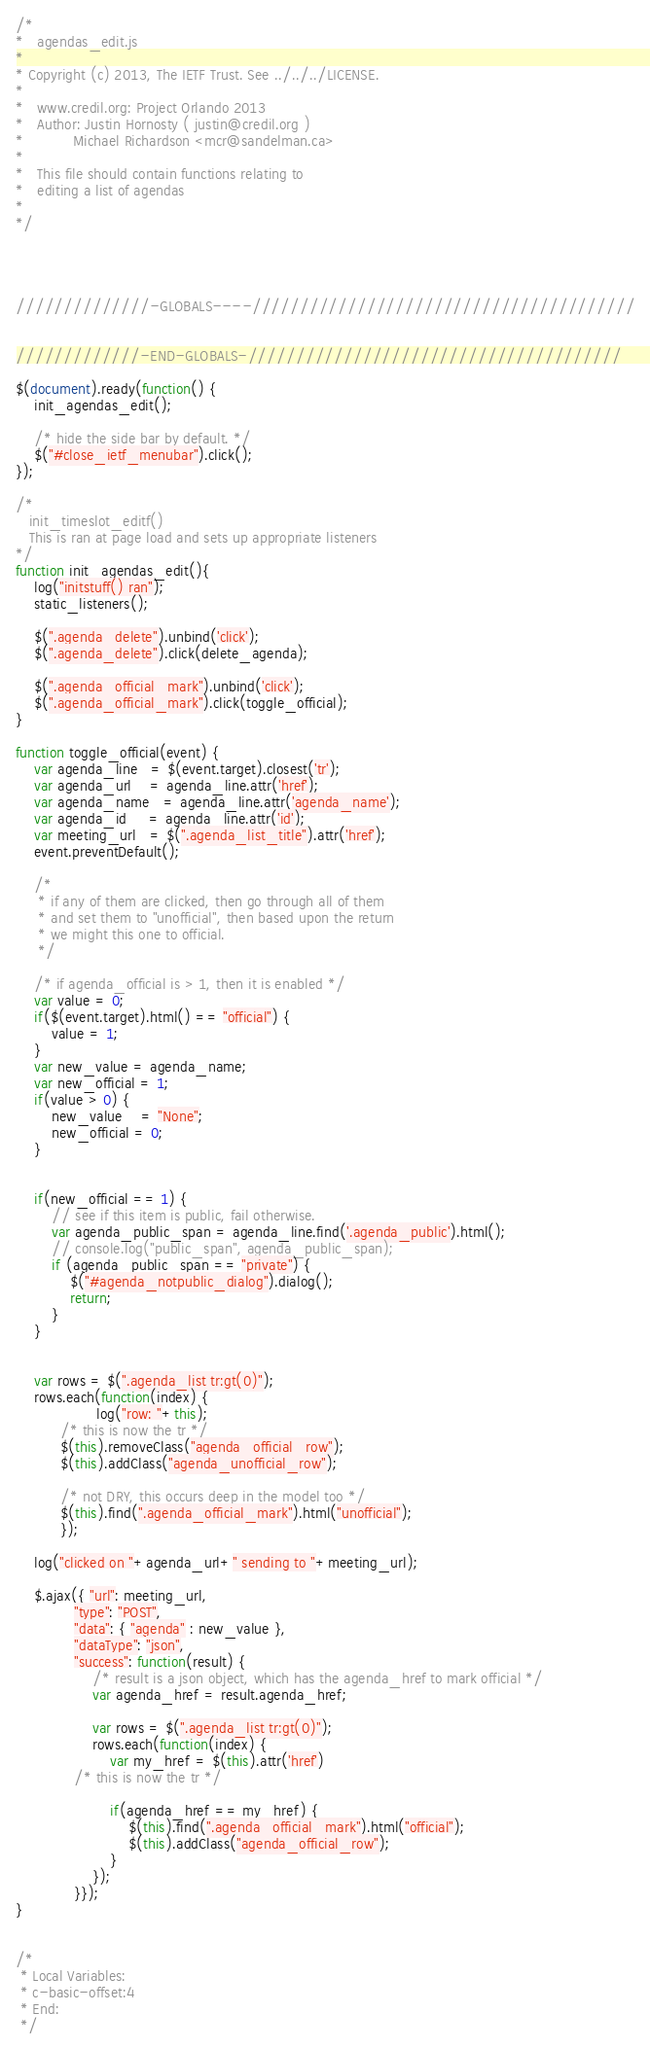Convert code to text. <code><loc_0><loc_0><loc_500><loc_500><_JavaScript_>/*
*   agendas_edit.js
*
* Copyright (c) 2013, The IETF Trust. See ../../../LICENSE.
*
*   www.credil.org: Project Orlando 2013 
*   Author: Justin Hornosty ( justin@credil.org )
*           Michael Richardson <mcr@sandelman.ca>
*
*   This file should contain functions relating to
*   editing a list of agendas
*
*/




//////////////-GLOBALS----////////////////////////////////////////


/////////////-END-GLOBALS-///////////////////////////////////////

$(document).ready(function() {
    init_agendas_edit();

    /* hide the side bar by default. */
    $("#close_ietf_menubar").click();
});

/*
   init_timeslot_editf()
   This is ran at page load and sets up appropriate listeners
*/
function init_agendas_edit(){
    log("initstuff() ran");
    static_listeners();

    $(".agenda_delete").unbind('click');
    $(".agenda_delete").click(delete_agenda);

    $(".agenda_official_mark").unbind('click');
    $(".agenda_official_mark").click(toggle_official);
}

function toggle_official(event) {
    var agenda_line   = $(event.target).closest('tr');
    var agenda_url    = agenda_line.attr('href');
    var agenda_name   = agenda_line.attr('agenda_name');
    var agenda_id     = agenda_line.attr('id');
    var meeting_url   = $(".agenda_list_title").attr('href');
    event.preventDefault();

    /*
     * if any of them are clicked, then go through all of them
     * and set them to "unofficial", then based upon the return
     * we might this one to official.
     */

    /* if agenda_official is > 1, then it is enabled */
    var value = 0;
    if($(event.target).html() == "official") {
        value = 1;
    }
    var new_value = agenda_name;
    var new_official = 1;
    if(value > 0) {
        new_value    = "None";
        new_official = 0;
    }


    if(new_official == 1) {
        // see if this item is public, fail otherwise.
        var agenda_public_span = agenda_line.find('.agenda_public').html();
        // console.log("public_span", agenda_public_span);
        if (agenda_public_span == "private") {
            $("#agenda_notpublic_dialog").dialog();
            return;
        }
    }


    var rows = $(".agenda_list tr:gt(0)");
    rows.each(function(index) {
                  log("row: "+this);
		  /* this is now the tr */
		  $(this).removeClass("agenda_official_row");
		  $(this).addClass("agenda_unofficial_row");

		  /* not DRY, this occurs deep in the model too */
		  $(this).find(".agenda_official_mark").html("unofficial");
	      });

    log("clicked on "+agenda_url+" sending to "+meeting_url);

    $.ajax({ "url": meeting_url,
             "type": "POST",
             "data": { "agenda" : new_value },
             "dataType": "json",
             "success": function(result) {
                 /* result is a json object, which has the agenda_href to mark official */
                 var agenda_href = result.agenda_href;

                 var rows = $(".agenda_list tr:gt(0)");
                 rows.each(function(index) {
                     var my_href = $(this).attr('href')
		     /* this is now the tr */

                     if(agenda_href == my_href) {
                         $(this).find(".agenda_official_mark").html("official");
                         $(this).addClass("agenda_official_row");
                     }
                 });
             }});
}


/*
 * Local Variables:
 * c-basic-offset:4
 * End:
 */

</code> 